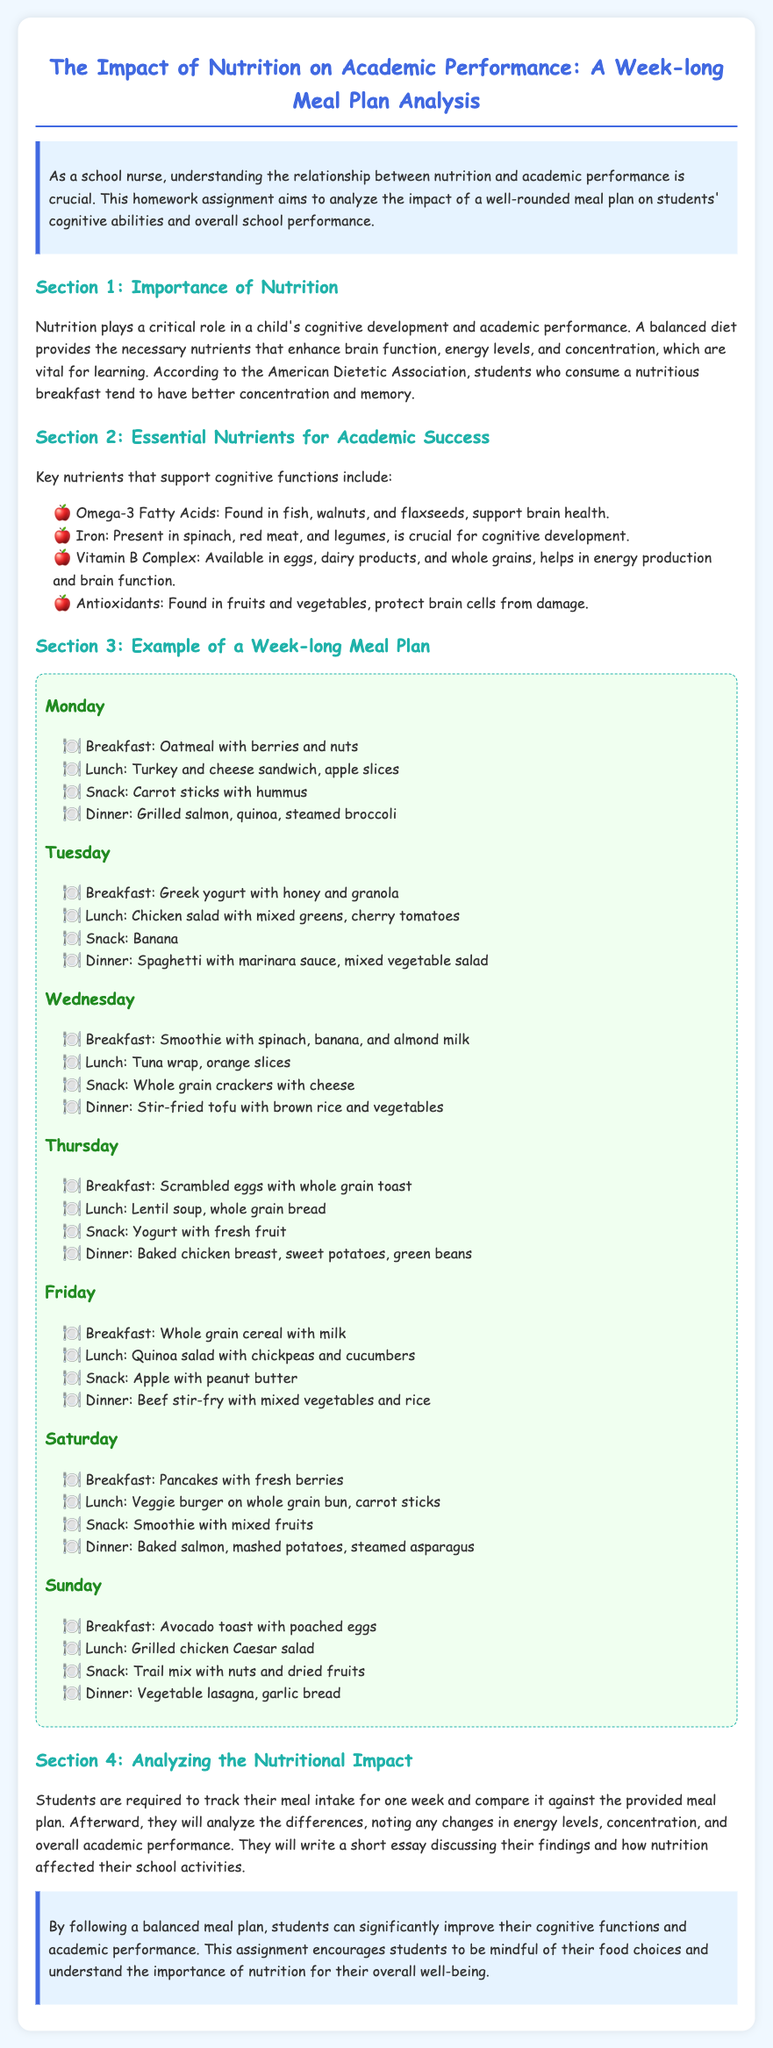what is the title of the document? The title is found in the header of the document, which indicates the main topic of the analysis.
Answer: The Impact of Nutrition on Academic Performance: A Week-long Meal Plan Analysis what nutrient is found in fish and walnuts? The document states specific sources of nutrients which enhance brain health, one of which is listed under essential nutrients.
Answer: Omega-3 Fatty Acids what day of the week features pancakes for breakfast? The meal plan sections specify what is served on each day, including breakfast items.
Answer: Saturday what is served for lunch on Wednesday? The meal plan provides specific meals for each day, including lunch options listed under Wednesday.
Answer: Tuna wrap, orange slices how many meals are tracked over the week for analysis? The document mentions a meal tracking exercise for each day of the week, indicating the total count of meals involved.
Answer: 28 which nutrient is found in spinach and legumes? The essential nutrients section details their sources, highlighting crucial components for cognitive development.
Answer: Iron what type of essay are students required to write after tracking their meals? The document outlines the expected deliverable after the analysis of their meal intake, defining the type of writing required.
Answer: Short essay what is the color theme of the document background? The background of the document is specified in the style section, indicating the overall visual design.
Answer: Light blue 